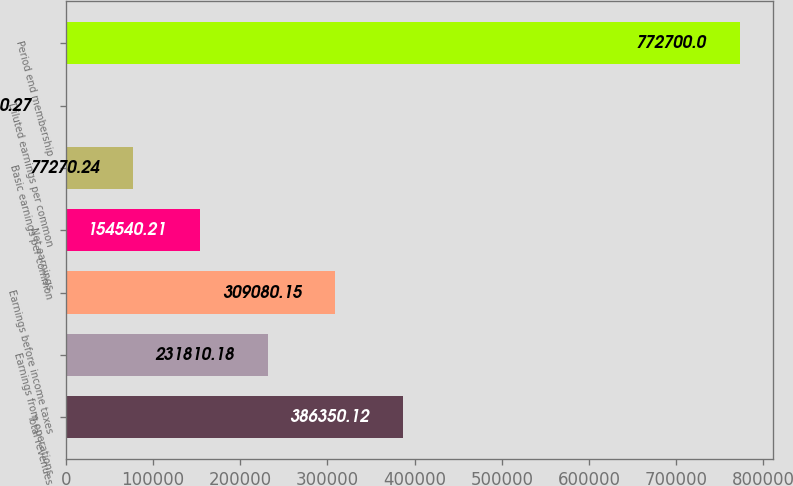Convert chart. <chart><loc_0><loc_0><loc_500><loc_500><bar_chart><fcel>Total revenues<fcel>Earnings from operations<fcel>Earnings before income taxes<fcel>Net earnings<fcel>Basic earnings per common<fcel>Diluted earnings per common<fcel>Period end membership<nl><fcel>386350<fcel>231810<fcel>309080<fcel>154540<fcel>77270.2<fcel>0.27<fcel>772700<nl></chart> 